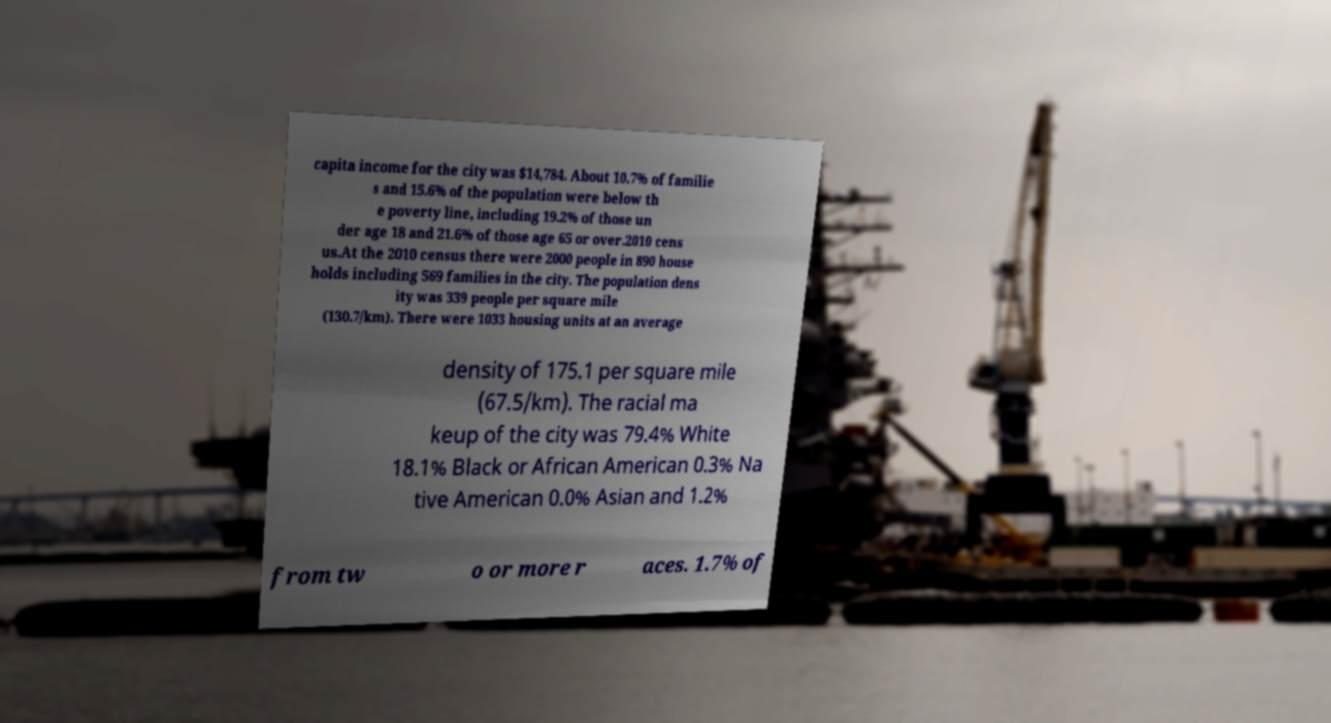Can you read and provide the text displayed in the image?This photo seems to have some interesting text. Can you extract and type it out for me? capita income for the city was $14,784. About 10.7% of familie s and 15.6% of the population were below th e poverty line, including 19.2% of those un der age 18 and 21.6% of those age 65 or over.2010 cens us.At the 2010 census there were 2000 people in 890 house holds including 569 families in the city. The population dens ity was 339 people per square mile (130.7/km). There were 1033 housing units at an average density of 175.1 per square mile (67.5/km). The racial ma keup of the city was 79.4% White 18.1% Black or African American 0.3% Na tive American 0.0% Asian and 1.2% from tw o or more r aces. 1.7% of 